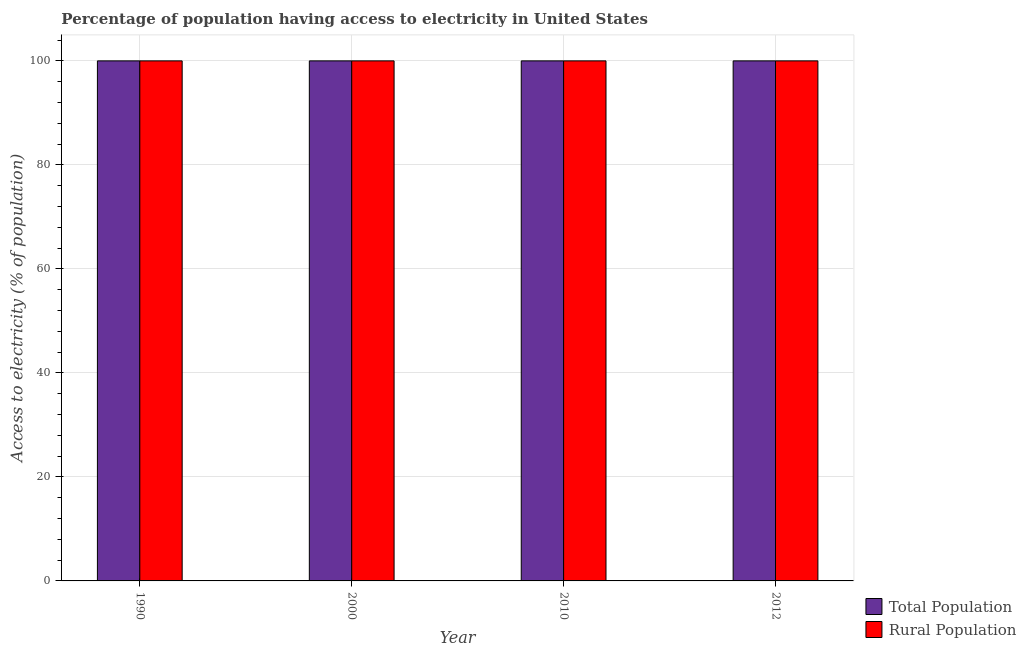How many groups of bars are there?
Offer a very short reply. 4. Are the number of bars on each tick of the X-axis equal?
Provide a succinct answer. Yes. How many bars are there on the 3rd tick from the right?
Ensure brevity in your answer.  2. What is the label of the 2nd group of bars from the left?
Offer a terse response. 2000. In how many cases, is the number of bars for a given year not equal to the number of legend labels?
Your answer should be very brief. 0. What is the percentage of population having access to electricity in 2010?
Ensure brevity in your answer.  100. Across all years, what is the maximum percentage of population having access to electricity?
Provide a short and direct response. 100. Across all years, what is the minimum percentage of rural population having access to electricity?
Give a very brief answer. 100. What is the total percentage of rural population having access to electricity in the graph?
Keep it short and to the point. 400. What is the difference between the percentage of population having access to electricity in 2000 and that in 2010?
Ensure brevity in your answer.  0. What is the average percentage of rural population having access to electricity per year?
Give a very brief answer. 100. What is the ratio of the percentage of rural population having access to electricity in 2000 to that in 2010?
Keep it short and to the point. 1. What is the difference between the highest and the second highest percentage of population having access to electricity?
Your answer should be very brief. 0. What does the 1st bar from the left in 2010 represents?
Keep it short and to the point. Total Population. What does the 2nd bar from the right in 1990 represents?
Ensure brevity in your answer.  Total Population. How many bars are there?
Provide a short and direct response. 8. Are all the bars in the graph horizontal?
Offer a very short reply. No. Does the graph contain any zero values?
Make the answer very short. No. How many legend labels are there?
Provide a short and direct response. 2. How are the legend labels stacked?
Give a very brief answer. Vertical. What is the title of the graph?
Give a very brief answer. Percentage of population having access to electricity in United States. What is the label or title of the X-axis?
Your response must be concise. Year. What is the label or title of the Y-axis?
Offer a terse response. Access to electricity (% of population). What is the Access to electricity (% of population) in Rural Population in 1990?
Ensure brevity in your answer.  100. What is the Access to electricity (% of population) of Total Population in 2000?
Your response must be concise. 100. What is the Access to electricity (% of population) in Rural Population in 2000?
Ensure brevity in your answer.  100. What is the Access to electricity (% of population) in Total Population in 2012?
Give a very brief answer. 100. Across all years, what is the maximum Access to electricity (% of population) of Total Population?
Offer a terse response. 100. Across all years, what is the minimum Access to electricity (% of population) of Rural Population?
Provide a succinct answer. 100. What is the total Access to electricity (% of population) of Total Population in the graph?
Offer a very short reply. 400. What is the total Access to electricity (% of population) of Rural Population in the graph?
Make the answer very short. 400. What is the difference between the Access to electricity (% of population) in Total Population in 1990 and that in 2000?
Provide a succinct answer. 0. What is the difference between the Access to electricity (% of population) of Rural Population in 1990 and that in 2000?
Your answer should be compact. 0. What is the difference between the Access to electricity (% of population) in Total Population in 1990 and that in 2010?
Your response must be concise. 0. What is the difference between the Access to electricity (% of population) of Total Population in 1990 and that in 2012?
Offer a terse response. 0. What is the difference between the Access to electricity (% of population) in Rural Population in 1990 and that in 2012?
Offer a very short reply. 0. What is the difference between the Access to electricity (% of population) of Total Population in 2000 and that in 2010?
Your response must be concise. 0. What is the difference between the Access to electricity (% of population) in Rural Population in 2000 and that in 2010?
Your answer should be very brief. 0. What is the difference between the Access to electricity (% of population) in Total Population in 2000 and that in 2012?
Your response must be concise. 0. What is the difference between the Access to electricity (% of population) in Total Population in 2010 and that in 2012?
Keep it short and to the point. 0. What is the difference between the Access to electricity (% of population) of Rural Population in 2010 and that in 2012?
Your answer should be compact. 0. What is the difference between the Access to electricity (% of population) in Total Population in 1990 and the Access to electricity (% of population) in Rural Population in 2010?
Give a very brief answer. 0. What is the difference between the Access to electricity (% of population) in Total Population in 1990 and the Access to electricity (% of population) in Rural Population in 2012?
Make the answer very short. 0. What is the difference between the Access to electricity (% of population) of Total Population in 2000 and the Access to electricity (% of population) of Rural Population in 2012?
Provide a succinct answer. 0. What is the average Access to electricity (% of population) of Total Population per year?
Give a very brief answer. 100. What is the average Access to electricity (% of population) in Rural Population per year?
Offer a terse response. 100. In the year 1990, what is the difference between the Access to electricity (% of population) of Total Population and Access to electricity (% of population) of Rural Population?
Provide a succinct answer. 0. In the year 2000, what is the difference between the Access to electricity (% of population) of Total Population and Access to electricity (% of population) of Rural Population?
Your answer should be compact. 0. In the year 2010, what is the difference between the Access to electricity (% of population) in Total Population and Access to electricity (% of population) in Rural Population?
Give a very brief answer. 0. In the year 2012, what is the difference between the Access to electricity (% of population) of Total Population and Access to electricity (% of population) of Rural Population?
Keep it short and to the point. 0. What is the ratio of the Access to electricity (% of population) of Total Population in 1990 to that in 2000?
Offer a very short reply. 1. What is the ratio of the Access to electricity (% of population) of Rural Population in 1990 to that in 2000?
Keep it short and to the point. 1. What is the ratio of the Access to electricity (% of population) of Total Population in 1990 to that in 2010?
Your response must be concise. 1. What is the ratio of the Access to electricity (% of population) of Rural Population in 1990 to that in 2010?
Keep it short and to the point. 1. What is the ratio of the Access to electricity (% of population) of Total Population in 2000 to that in 2010?
Make the answer very short. 1. What is the ratio of the Access to electricity (% of population) in Rural Population in 2000 to that in 2010?
Make the answer very short. 1. What is the ratio of the Access to electricity (% of population) of Rural Population in 2000 to that in 2012?
Offer a very short reply. 1. What is the ratio of the Access to electricity (% of population) of Total Population in 2010 to that in 2012?
Provide a short and direct response. 1. What is the difference between the highest and the second highest Access to electricity (% of population) in Total Population?
Provide a short and direct response. 0. What is the difference between the highest and the second highest Access to electricity (% of population) in Rural Population?
Offer a very short reply. 0. What is the difference between the highest and the lowest Access to electricity (% of population) in Total Population?
Offer a terse response. 0. What is the difference between the highest and the lowest Access to electricity (% of population) of Rural Population?
Your answer should be very brief. 0. 